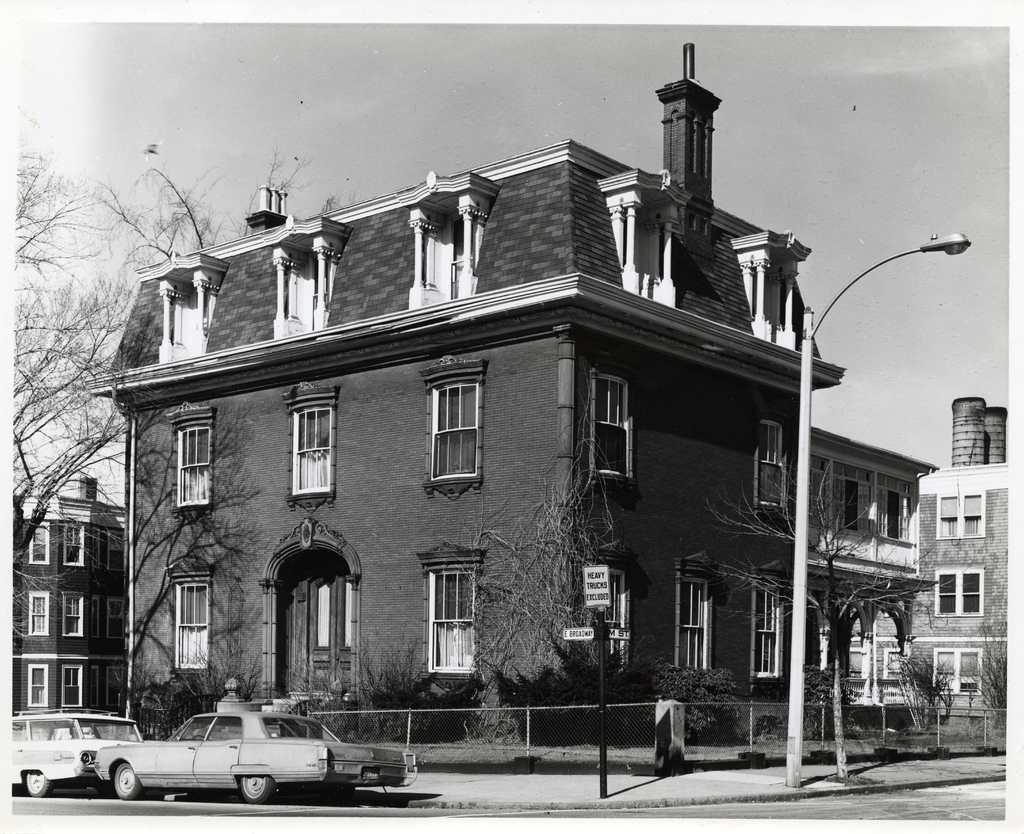What is the color scheme of the image? The image is black and white. What can be seen on the road in the image? There are vehicles on the road in the image. What type of structure is present in the image? There is a fence in the image. What other objects can be seen in the image? There are poles, boards, buildings, plants, and trees in the image. What is visible in the background of the image? The sky is visible in the background of the image. What type of birth can be seen in the image? There is no birth depicted in the image. What achievement is the person in the image celebrating? There is no person celebrating an achievement in the image. 